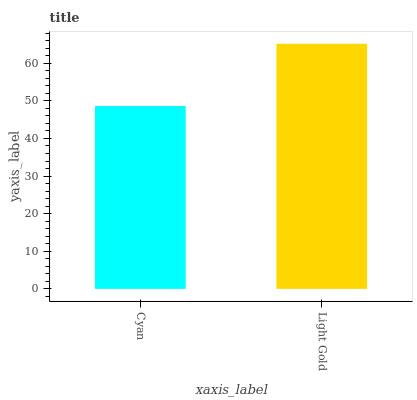Is Cyan the minimum?
Answer yes or no. Yes. Is Light Gold the maximum?
Answer yes or no. Yes. Is Light Gold the minimum?
Answer yes or no. No. Is Light Gold greater than Cyan?
Answer yes or no. Yes. Is Cyan less than Light Gold?
Answer yes or no. Yes. Is Cyan greater than Light Gold?
Answer yes or no. No. Is Light Gold less than Cyan?
Answer yes or no. No. Is Light Gold the high median?
Answer yes or no. Yes. Is Cyan the low median?
Answer yes or no. Yes. Is Cyan the high median?
Answer yes or no. No. Is Light Gold the low median?
Answer yes or no. No. 